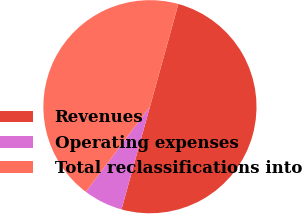<chart> <loc_0><loc_0><loc_500><loc_500><pie_chart><fcel>Revenues<fcel>Operating expenses<fcel>Total reclassifications into<nl><fcel>50.0%<fcel>5.98%<fcel>44.02%<nl></chart> 